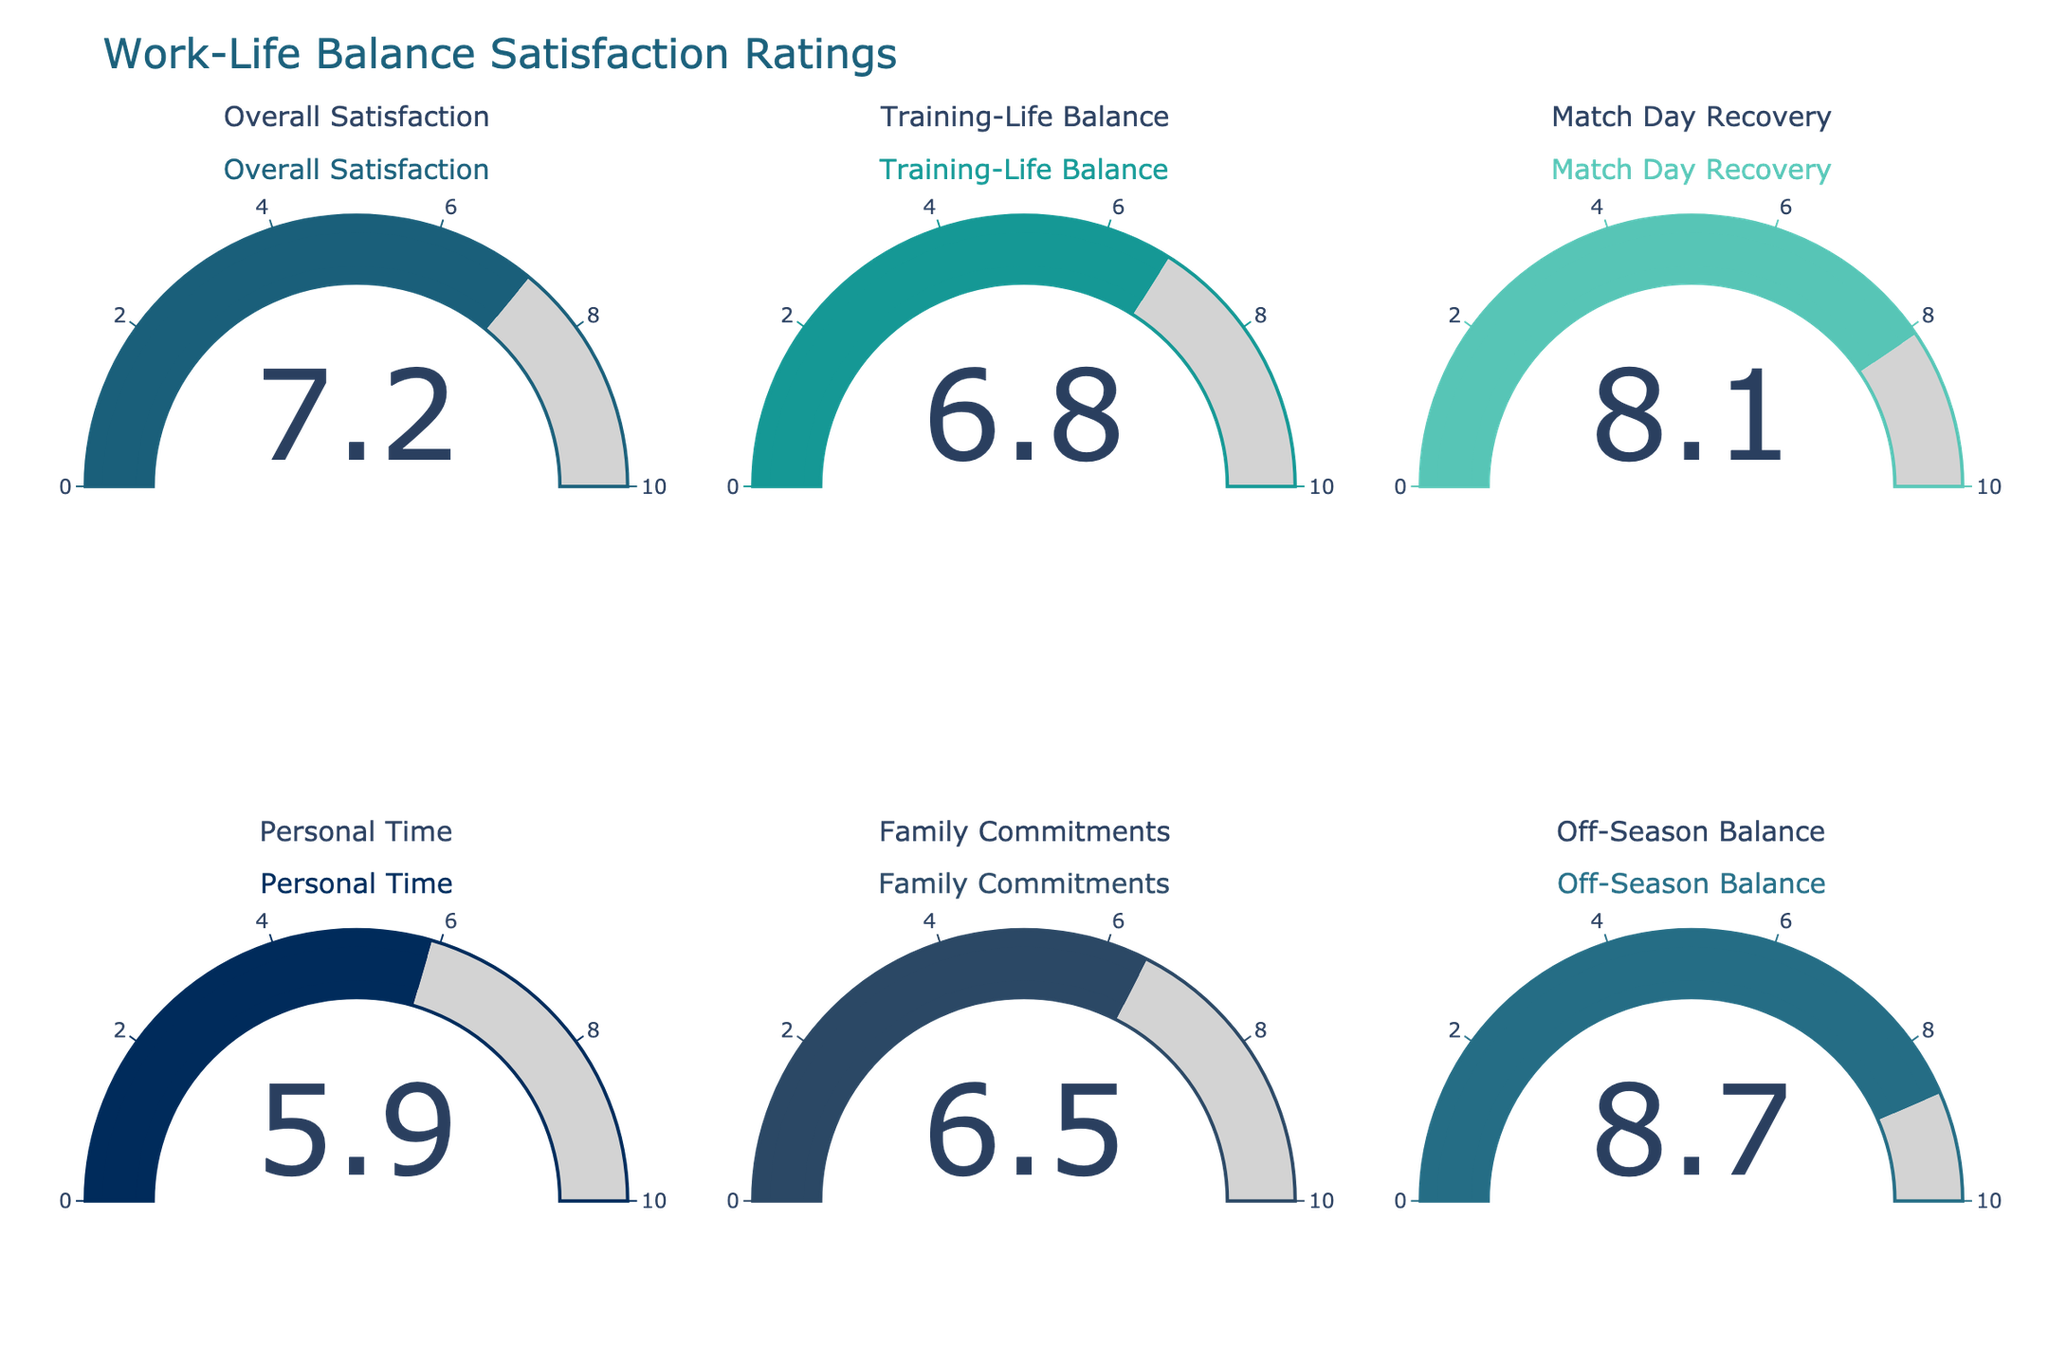What's the overall satisfaction rating displayed on the gauge chart? The gauge for "Overall Satisfaction" shows a number in the middle, which corresponds to the satisfaction rating.
Answer: 7.2 Which category has the highest satisfaction rating? By comparing the numbers on each gauge, the gauge for "Off-Season Balance" shows the highest value among all categories.
Answer: Off-Season Balance Which category has the lowest satisfaction rating? By comparing the displayed numbers on each gauge, the "Personal Time" gauge shows the lowest value.
Answer: Personal Time What is the average satisfaction rating across all categories? Sum all the values: 7.2 + 6.8 + 8.1 + 5.9 + 6.5 + 8.7 = 43.2. Then divide by the number of categories: 43.2 / 6 = 7.2.
Answer: 7.2 How much higher is the satisfaction rating for "Match Day Recovery" compared to "Family Commitments"? The satisfaction rating for "Match Day Recovery" is 8.1, and for "Family Commitments" is 6.5. Calculating the difference: 8.1 - 6.5 = 1.6.
Answer: 1.6 Which category shows a satisfaction rating closest to 7? Comparing all values, "Training-Life Balance" with a rating of 6.8 is closest to 7.
Answer: Training-Life Balance What is the range of satisfaction ratings displayed on the gauge charts? The highest rating is 8.7 (Off-Season Balance) and the lowest is 5.9 (Personal Time). Calculating the range: 8.7 - 5.9 = 2.8.
Answer: 2.8 How many categories have a satisfaction rating above 7? Count the categories with values above 7: "Overall Satisfaction" (7.2), "Match Day Recovery" (8.1), and "Off-Season Balance" (8.7). This sums to 3 categories.
Answer: 3 Is the satisfaction rating for "Training-Life Balance" greater than that for "Family Commitments"? Compare the values: "Training-Life Balance" is 6.8 and "Family Commitments" is 6.5. Yes, 6.8 is greater than 6.5.
Answer: Yes What is the median satisfaction rating across all categories? Listing the ratings in ascending order: 5.9, 6.5, 6.8, 7.2, 8.1, 8.7. The median value is the average of the 3rd and 4th values: (6.8 + 7.2) / 2 = 7.
Answer: 7 